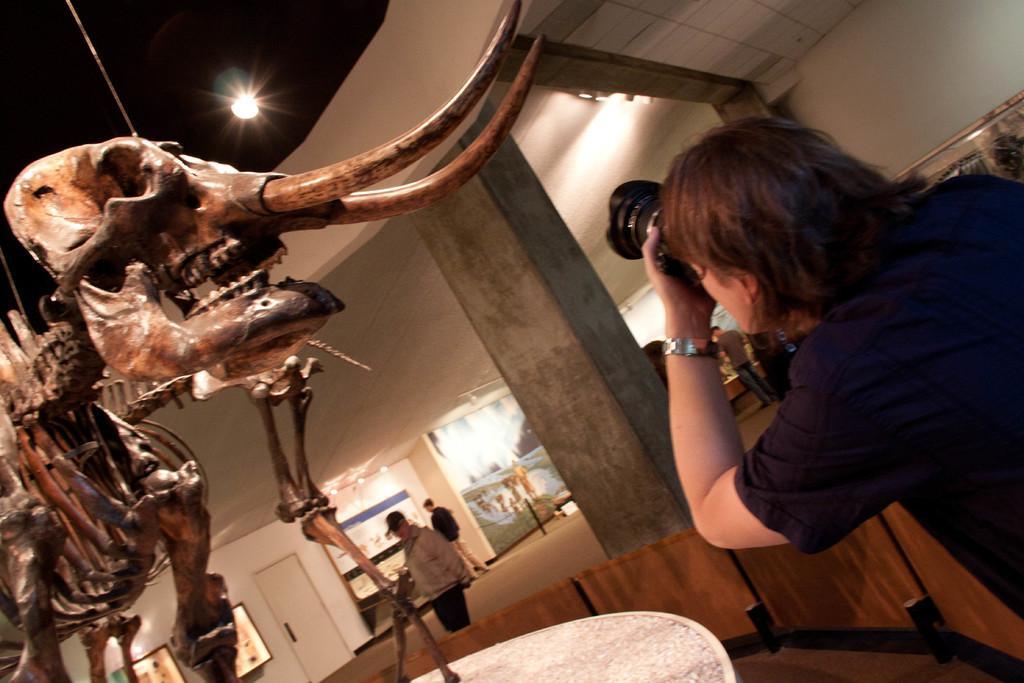Please provide a concise description of this image. On the right side, there is a person holding a camera and capturing a photo of an animal's skeleton, which is on a platform. In the background, there are lights arranged, there are two persons, there are paintings and a white wall. 